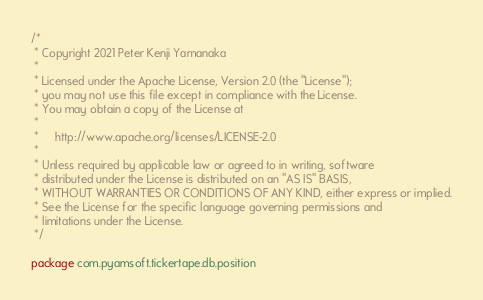Convert code to text. <code><loc_0><loc_0><loc_500><loc_500><_Kotlin_>/*
 * Copyright 2021 Peter Kenji Yamanaka
 *
 * Licensed under the Apache License, Version 2.0 (the "License");
 * you may not use this file except in compliance with the License.
 * You may obtain a copy of the License at
 *
 *     http://www.apache.org/licenses/LICENSE-2.0
 *
 * Unless required by applicable law or agreed to in writing, software
 * distributed under the License is distributed on an "AS IS" BASIS,
 * WITHOUT WARRANTIES OR CONDITIONS OF ANY KIND, either express or implied.
 * See the License for the specific language governing permissions and
 * limitations under the License.
 */

package com.pyamsoft.tickertape.db.position
</code> 